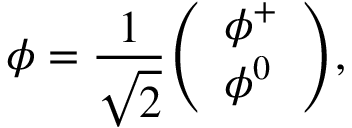Convert formula to latex. <formula><loc_0><loc_0><loc_500><loc_500>\phi = { \frac { 1 } { \sqrt { 2 } } } { \left ( \begin{array} { l } { \phi ^ { + } } \\ { \phi ^ { 0 } } \end{array} \right ) } ,</formula> 